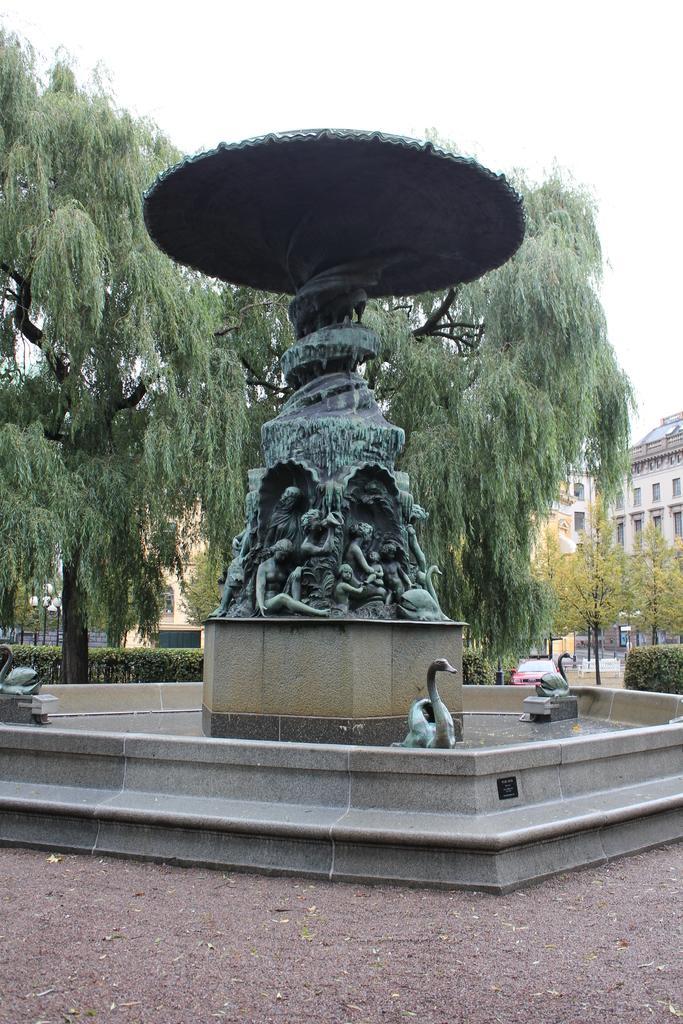Describe this image in one or two sentences. In the center of the image we can see the fountain. In the background of the image we can see the trees, buildings, cardboard. At the bottom of the image we can see the pavement. At the top of the image we can see the sky. 